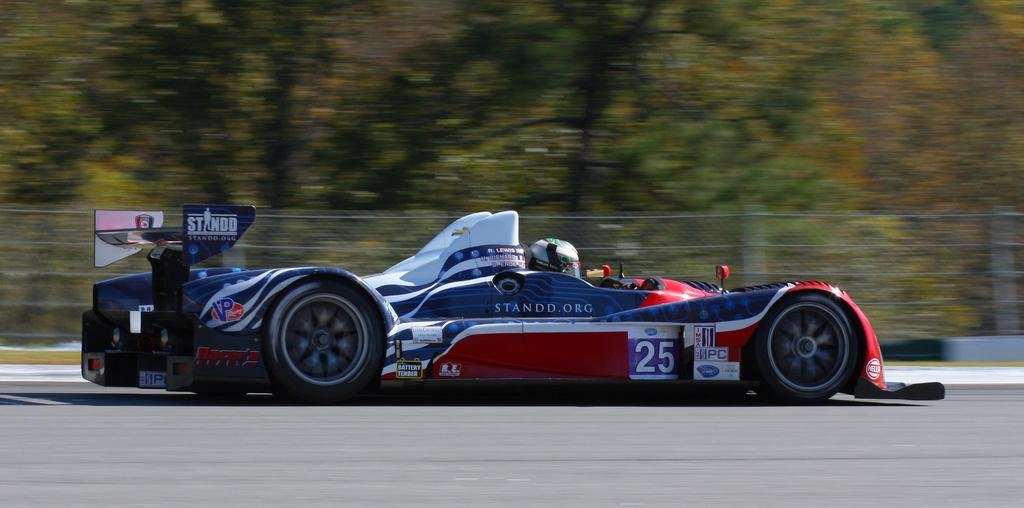What is the main subject of the image? The main subject of the image is a car. What colors can be seen on the car? The car has blue, red, and white colors. What type of natural elements are present in the image? There are trees in the image. What type of barrier can be seen in the image? There is fencing in the image. Where is the faucet located in the image? There is no faucet present in the image. How many additional colors can be seen on the car, besides blue, red, and white? The car only has blue, red, and white colors mentioned in the facts, so there are no additional colors. 